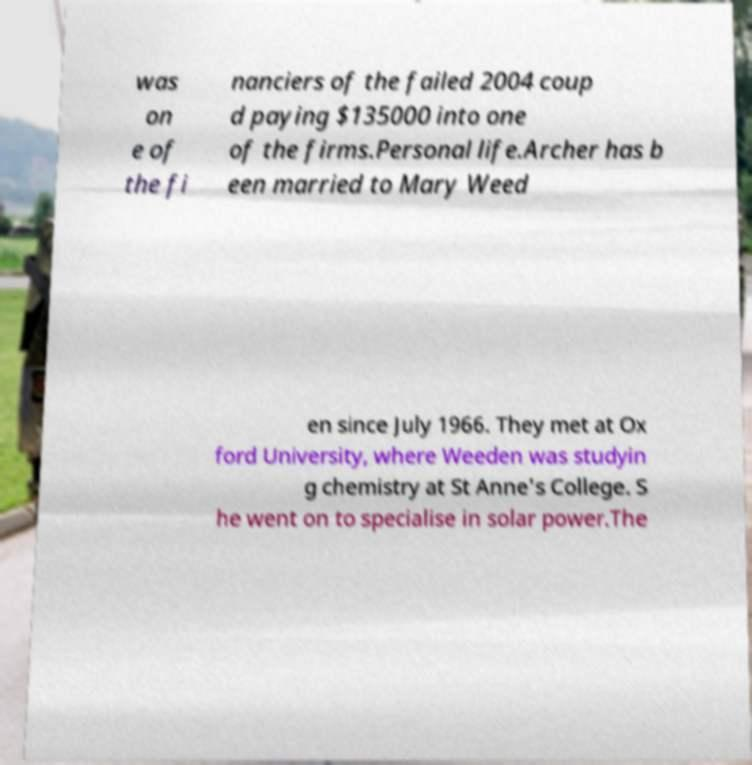What messages or text are displayed in this image? I need them in a readable, typed format. was on e of the fi nanciers of the failed 2004 coup d paying $135000 into one of the firms.Personal life.Archer has b een married to Mary Weed en since July 1966. They met at Ox ford University, where Weeden was studyin g chemistry at St Anne's College. S he went on to specialise in solar power.The 